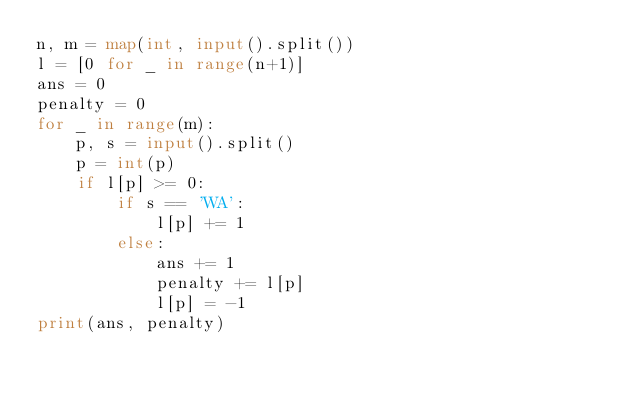<code> <loc_0><loc_0><loc_500><loc_500><_Python_>n, m = map(int, input().split())
l = [0 for _ in range(n+1)]
ans = 0
penalty = 0
for _ in range(m):
    p, s = input().split()
    p = int(p)
    if l[p] >= 0:
        if s == 'WA':
            l[p] += 1
        else:
            ans += 1
            penalty += l[p]
            l[p] = -1
print(ans, penalty)</code> 